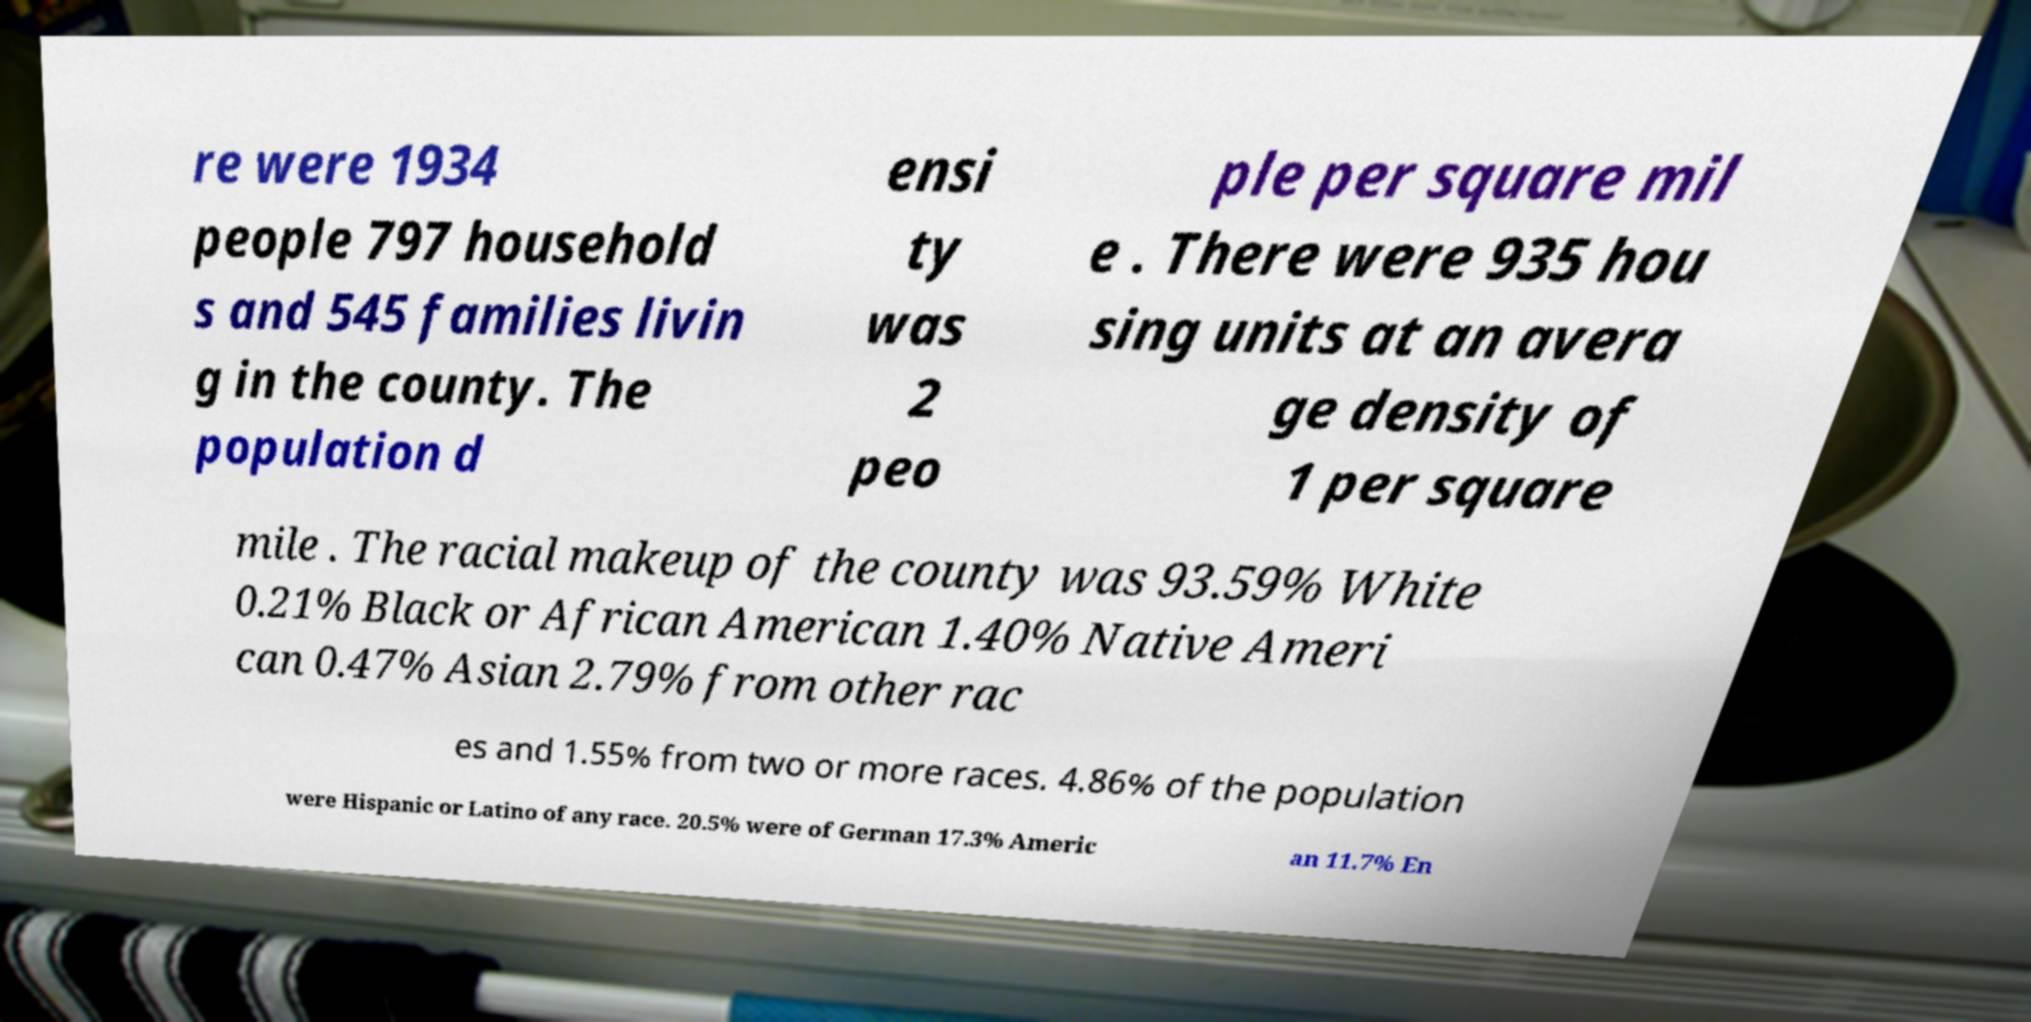I need the written content from this picture converted into text. Can you do that? re were 1934 people 797 household s and 545 families livin g in the county. The population d ensi ty was 2 peo ple per square mil e . There were 935 hou sing units at an avera ge density of 1 per square mile . The racial makeup of the county was 93.59% White 0.21% Black or African American 1.40% Native Ameri can 0.47% Asian 2.79% from other rac es and 1.55% from two or more races. 4.86% of the population were Hispanic or Latino of any race. 20.5% were of German 17.3% Americ an 11.7% En 